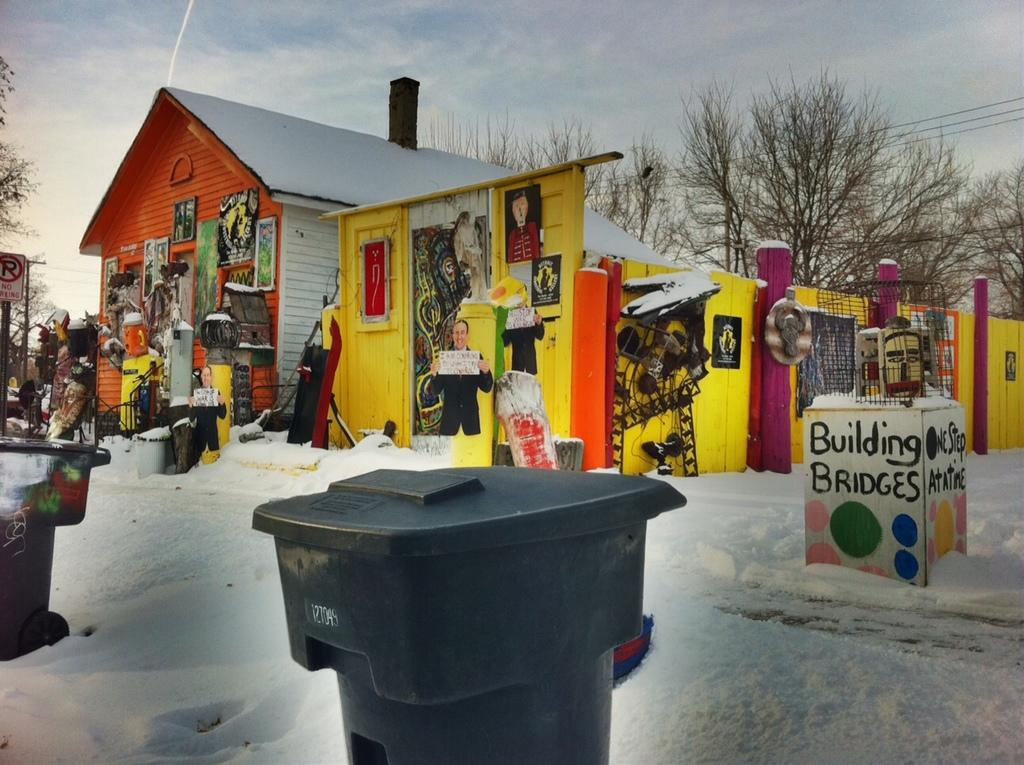<image>
Offer a succinct explanation of the picture presented. Next to a very bright orange and yellow building is a small, square structure that says building bridges. 